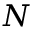<formula> <loc_0><loc_0><loc_500><loc_500>N</formula> 